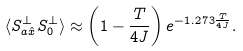Convert formula to latex. <formula><loc_0><loc_0><loc_500><loc_500>\langle S _ { a \hat { x } } ^ { \perp } S _ { 0 } ^ { \perp } \rangle \approx \left ( 1 - \frac { T } { 4 J } \right ) e ^ { - 1 . 2 7 3 \frac { T } { 4 J } } .</formula> 